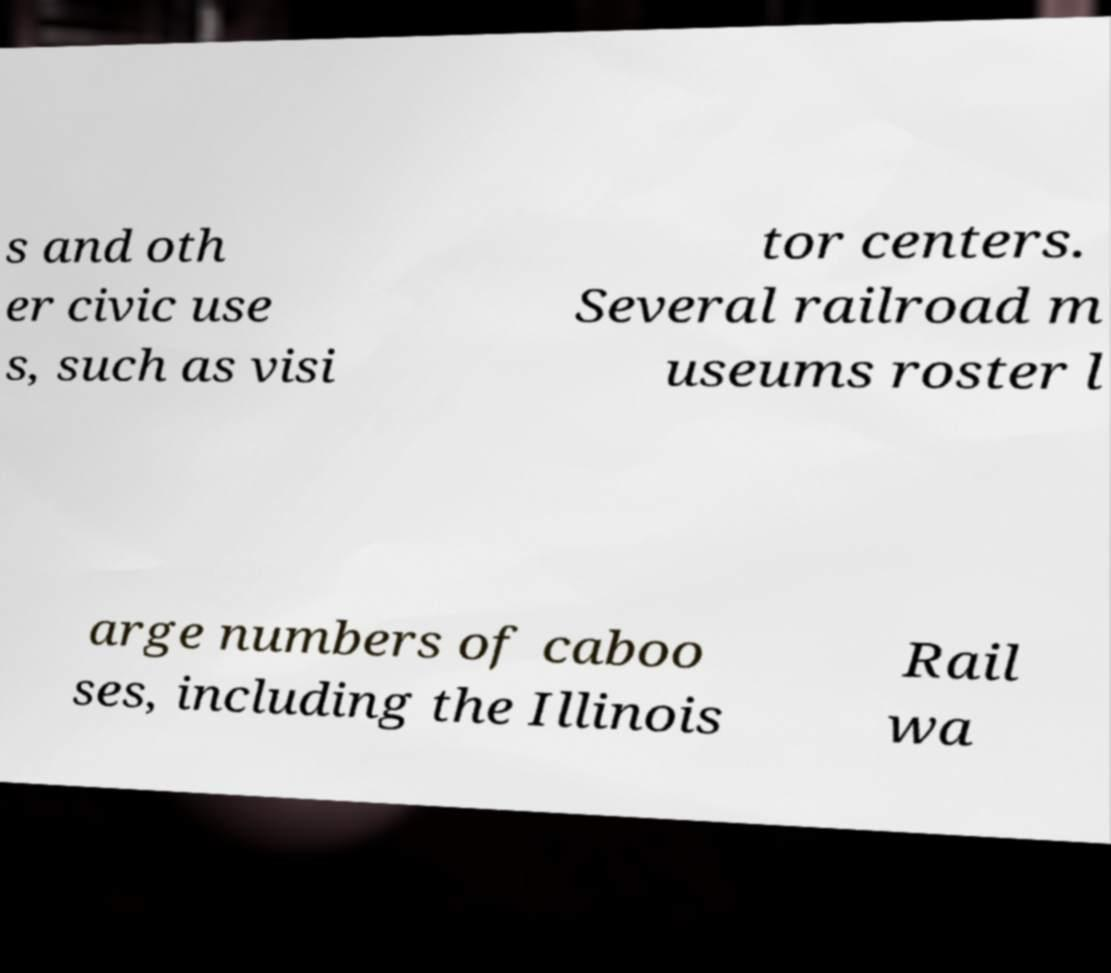There's text embedded in this image that I need extracted. Can you transcribe it verbatim? s and oth er civic use s, such as visi tor centers. Several railroad m useums roster l arge numbers of caboo ses, including the Illinois Rail wa 